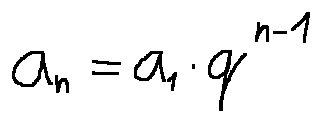<formula> <loc_0><loc_0><loc_500><loc_500>a _ { n } = a _ { 1 } \cdot q ^ { n - 1 }</formula> 